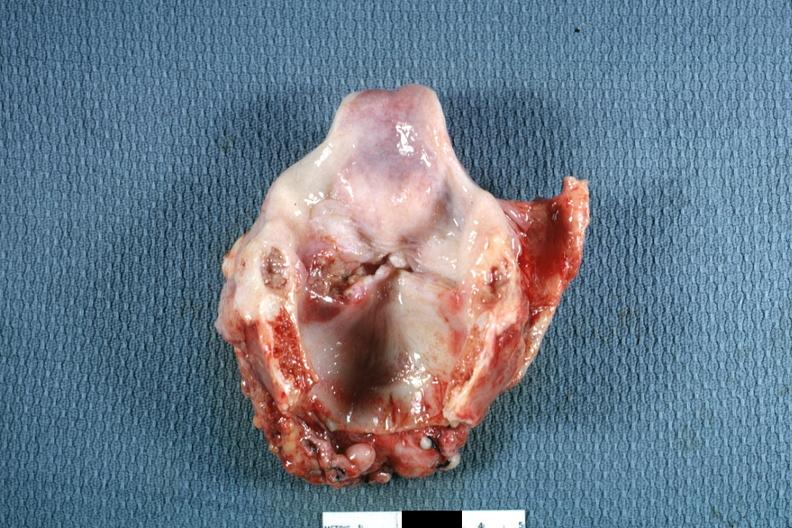what is present?
Answer the question using a single word or phrase. Squamous cell carcinoma 